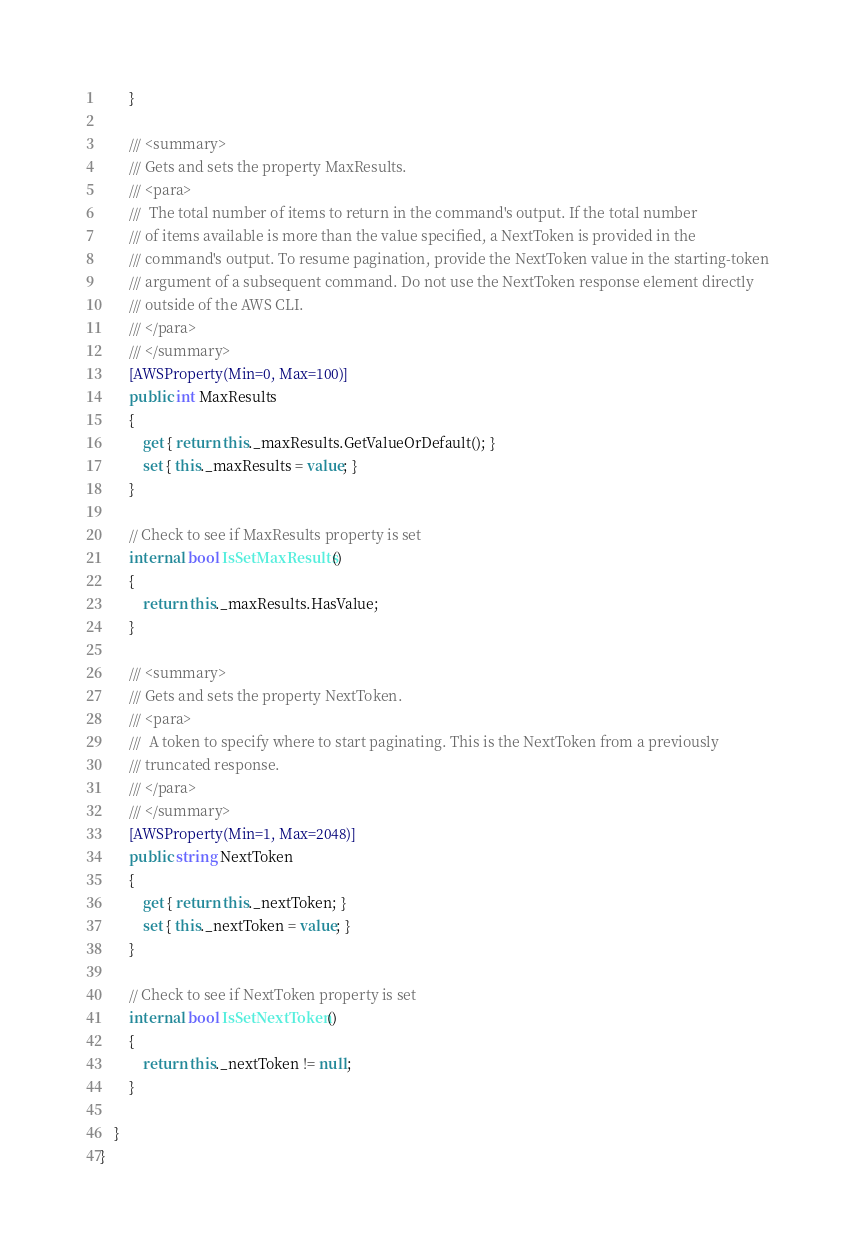Convert code to text. <code><loc_0><loc_0><loc_500><loc_500><_C#_>        }

        /// <summary>
        /// Gets and sets the property MaxResults. 
        /// <para>
        ///  The total number of items to return in the command's output. If the total number
        /// of items available is more than the value specified, a NextToken is provided in the
        /// command's output. To resume pagination, provide the NextToken value in the starting-token
        /// argument of a subsequent command. Do not use the NextToken response element directly
        /// outside of the AWS CLI. 
        /// </para>
        /// </summary>
        [AWSProperty(Min=0, Max=100)]
        public int MaxResults
        {
            get { return this._maxResults.GetValueOrDefault(); }
            set { this._maxResults = value; }
        }

        // Check to see if MaxResults property is set
        internal bool IsSetMaxResults()
        {
            return this._maxResults.HasValue; 
        }

        /// <summary>
        /// Gets and sets the property NextToken. 
        /// <para>
        ///  A token to specify where to start paginating. This is the NextToken from a previously
        /// truncated response. 
        /// </para>
        /// </summary>
        [AWSProperty(Min=1, Max=2048)]
        public string NextToken
        {
            get { return this._nextToken; }
            set { this._nextToken = value; }
        }

        // Check to see if NextToken property is set
        internal bool IsSetNextToken()
        {
            return this._nextToken != null;
        }

    }
}</code> 